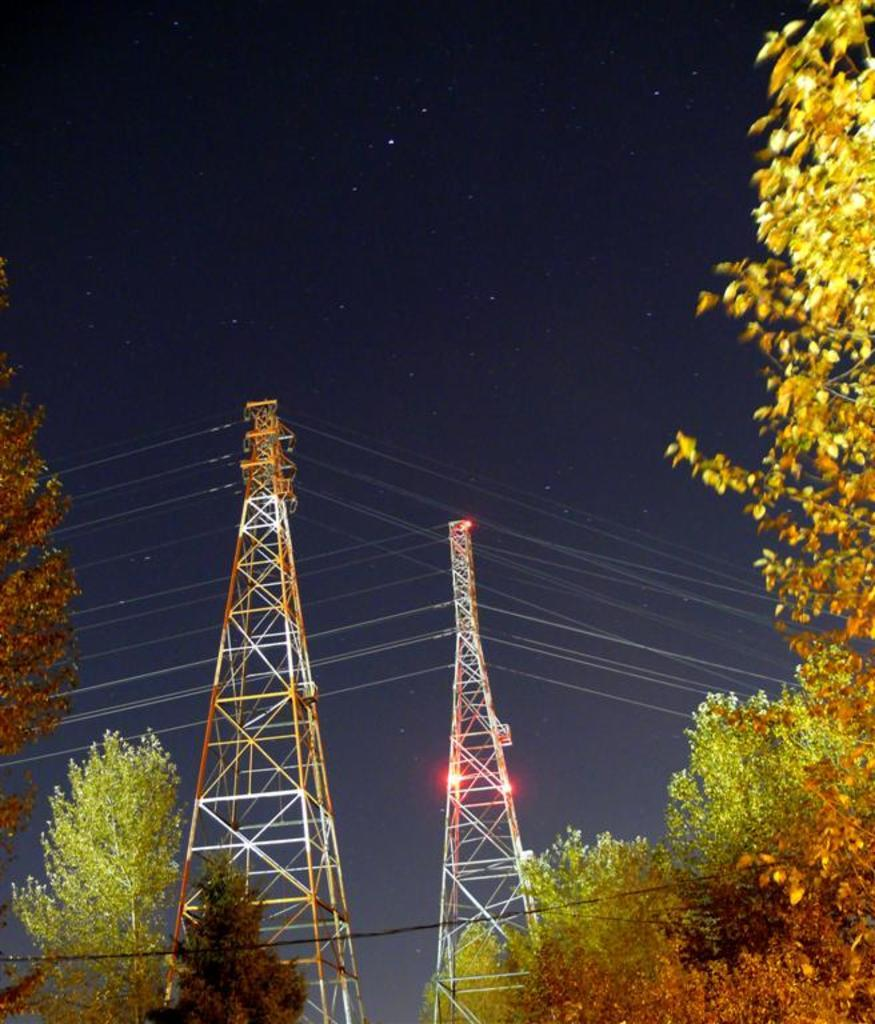What type of vegetation is present at the bottom of the image? There are trees at the bottom of the image. What can be seen on the left side of the image? There are trees on the left side of the image. What is visible on the right side of the image? There are trees on the right side of the image. What structures are located in the background of the image? There are towers in the background of the image. What else can be seen in the background of the image? There are lights and electric wires in the background of the image. What celestial objects are visible in the sky in the background of the image? Stars are visible in the sky in the background of the image. What type of cloud can be seen in the image? There is no cloud present in the image. 